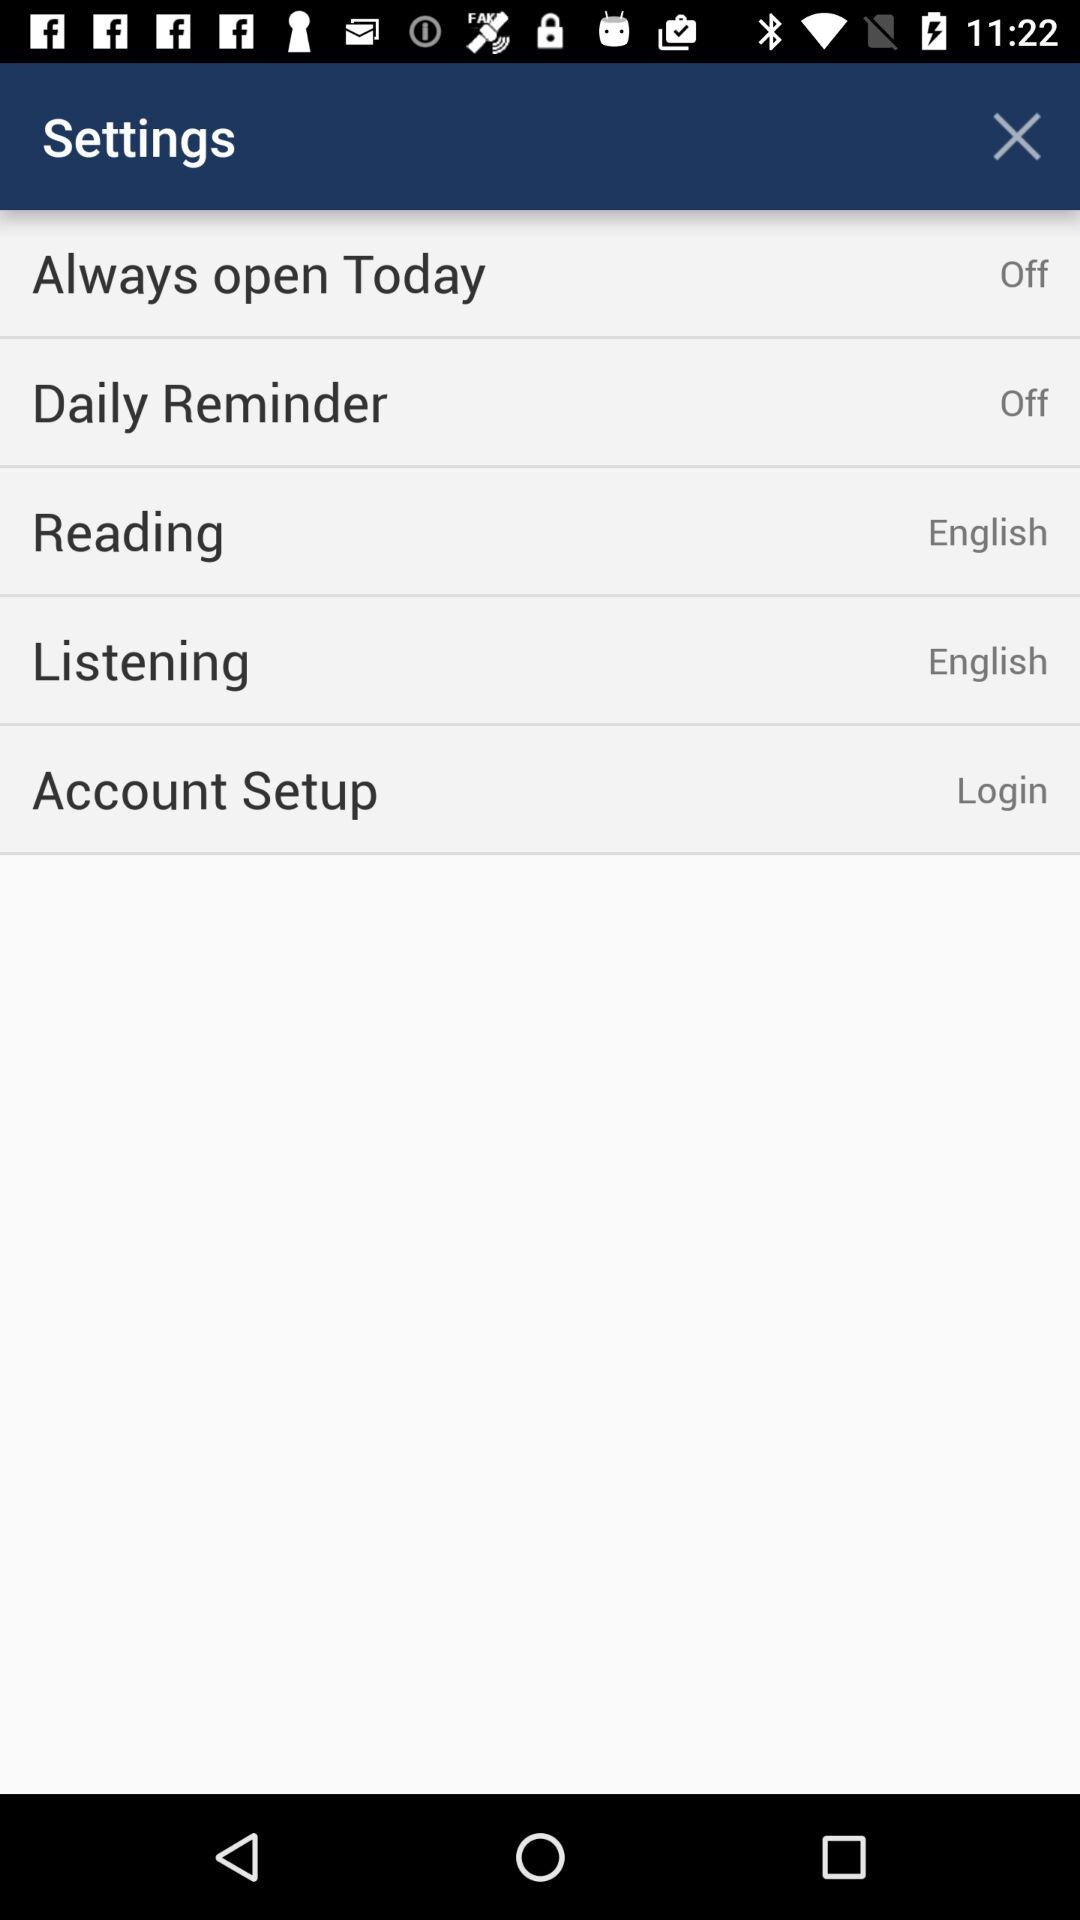What is the status of "Always open Today"? The status of "Always open Today" is "off". 